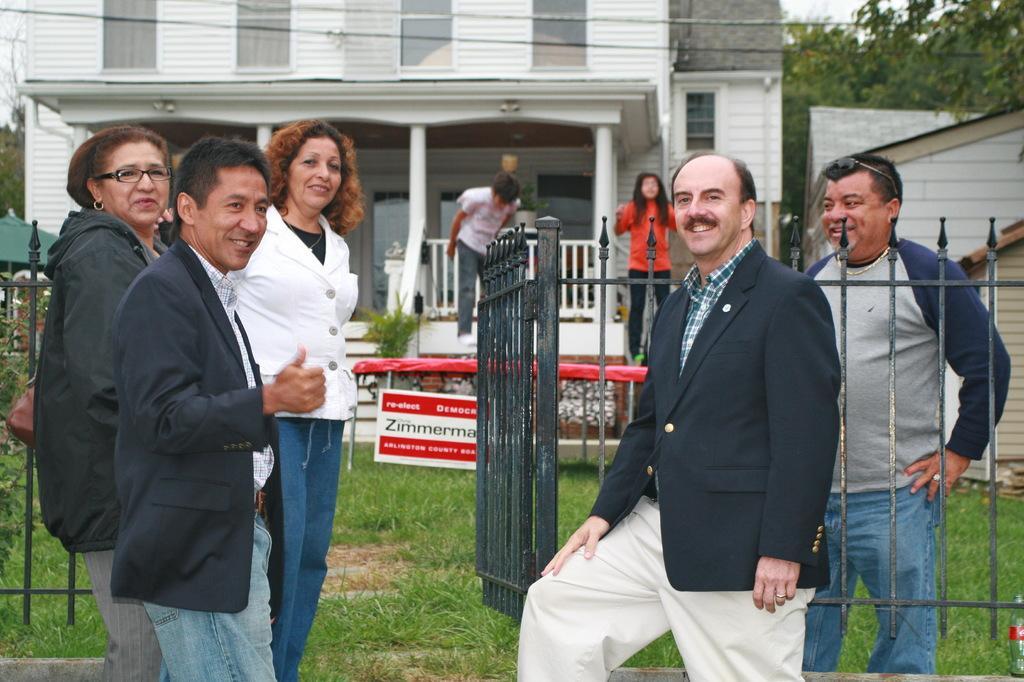How would you summarize this image in a sentence or two? In the picture we can see some people are standing near the railing and they are smiling and behind the railing we can see one man is standing on the grass surface and he is also smiling and behind him we can see a house with some pillars, and railing and two people standing near it and beside the house we can see some other houses and behind it we can see trees and some part of the sky. 